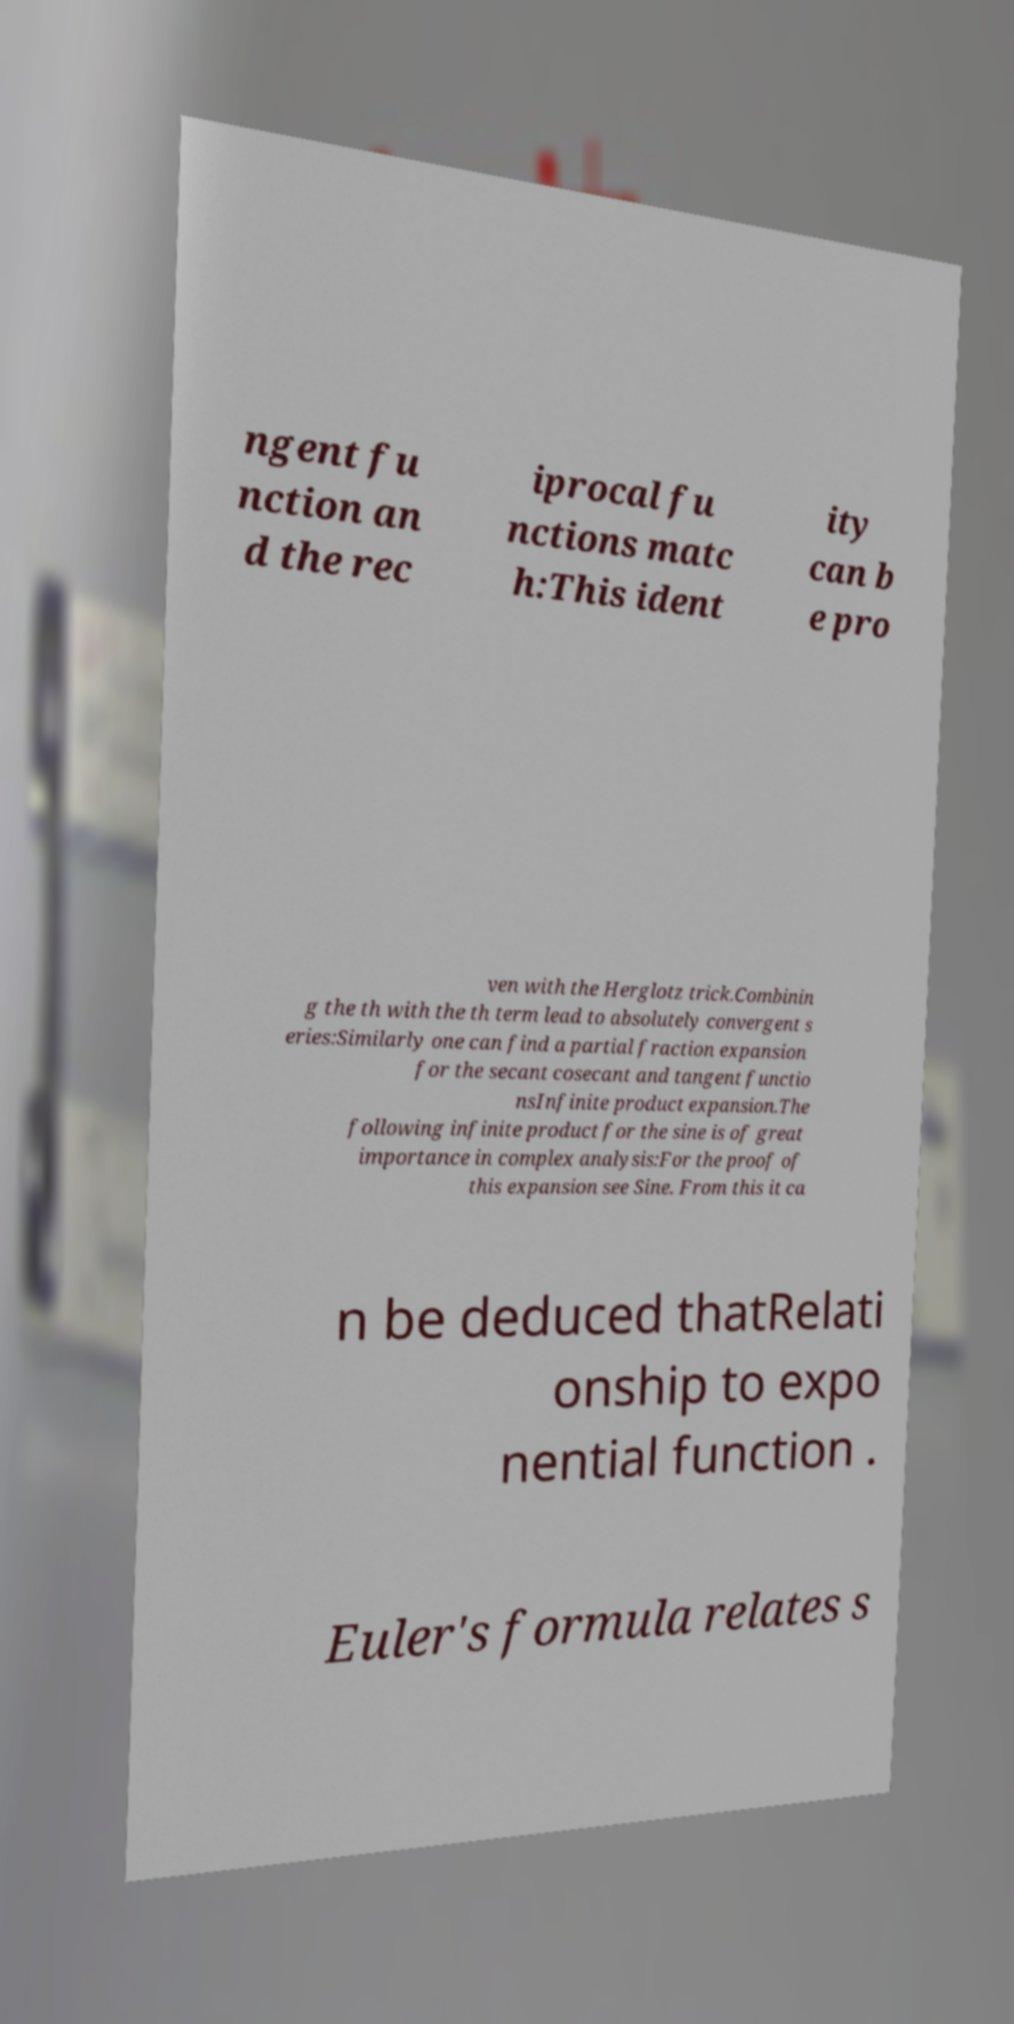I need the written content from this picture converted into text. Can you do that? ngent fu nction an d the rec iprocal fu nctions matc h:This ident ity can b e pro ven with the Herglotz trick.Combinin g the th with the th term lead to absolutely convergent s eries:Similarly one can find a partial fraction expansion for the secant cosecant and tangent functio nsInfinite product expansion.The following infinite product for the sine is of great importance in complex analysis:For the proof of this expansion see Sine. From this it ca n be deduced thatRelati onship to expo nential function . Euler's formula relates s 